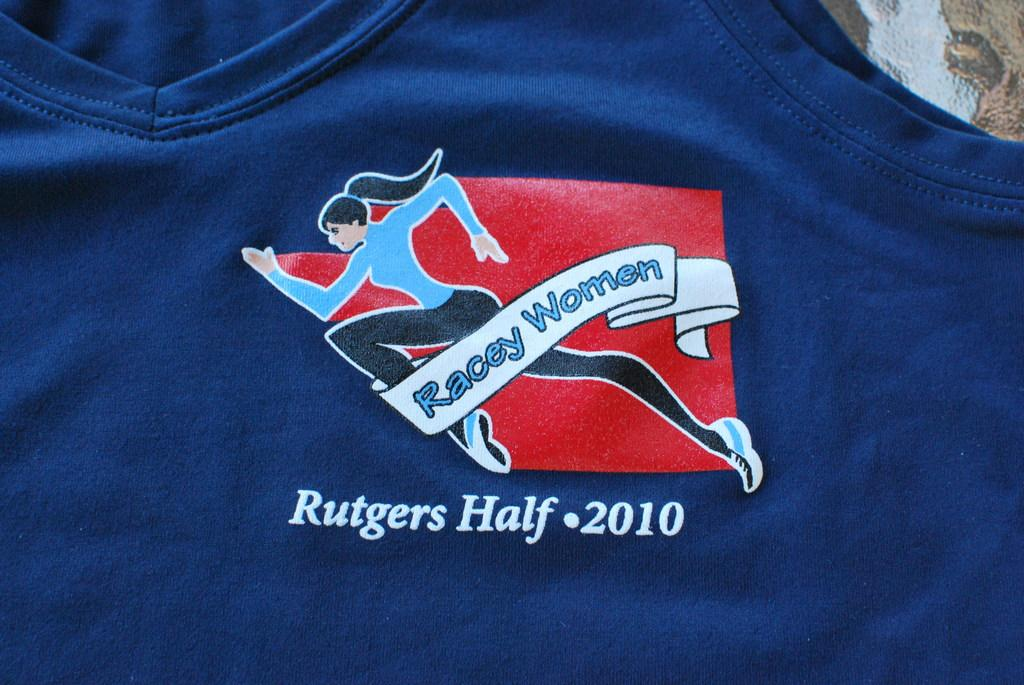<image>
Present a compact description of the photo's key features. A blue t-shirt with a Rutgers Half marathon logo on the front. 